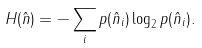<formula> <loc_0><loc_0><loc_500><loc_500>H ( \hat { n } ) = - \sum _ { i } p ( \hat { n } _ { i } ) \log _ { 2 } p ( \hat { n } _ { i } ) .</formula> 